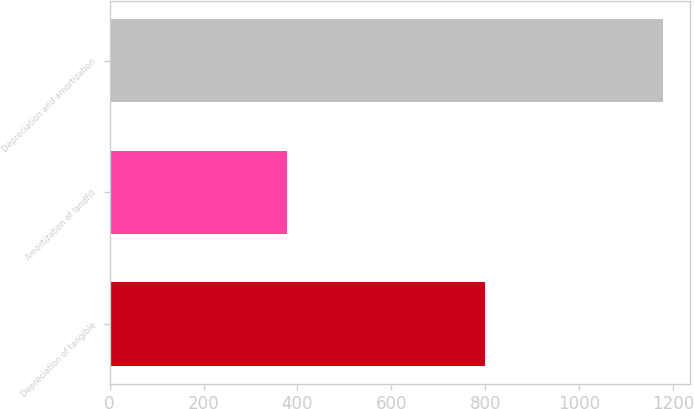Convert chart. <chart><loc_0><loc_0><loc_500><loc_500><bar_chart><fcel>Depreciation of tangible<fcel>Amortization of landfill<fcel>Depreciation and amortization<nl><fcel>800<fcel>378<fcel>1178<nl></chart> 